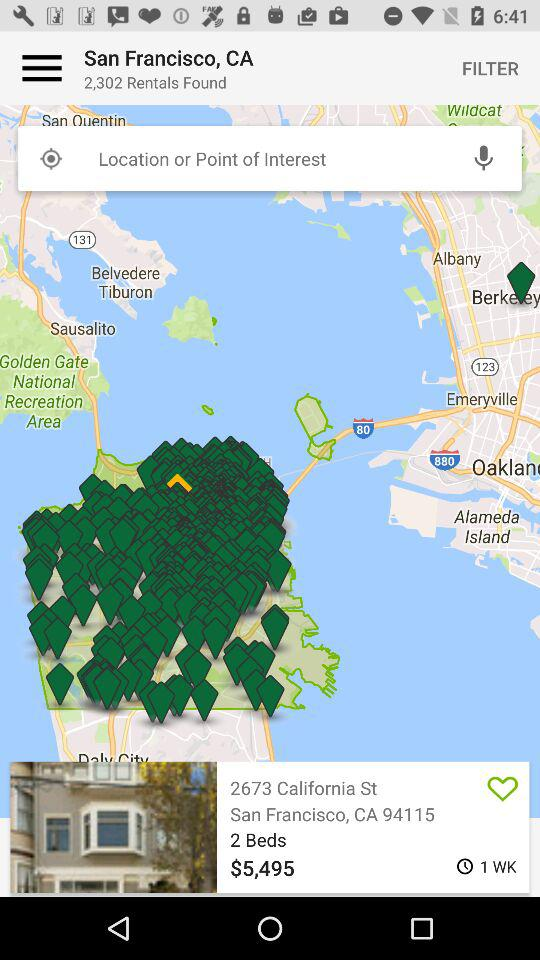How many bedrooms are there in the rental with a price of $5,495?
Answer the question using a single word or phrase. 2 